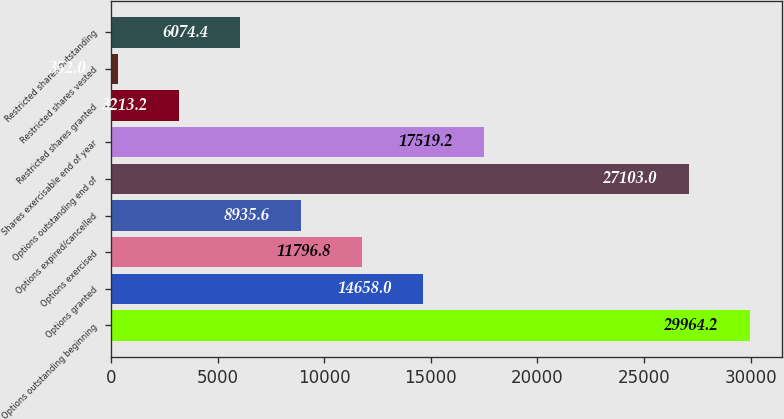Convert chart. <chart><loc_0><loc_0><loc_500><loc_500><bar_chart><fcel>Options outstanding beginning<fcel>Options granted<fcel>Options exercised<fcel>Options expired/cancelled<fcel>Options outstanding end of<fcel>Shares exercisable end of year<fcel>Restricted shares granted<fcel>Restricted shares vested<fcel>Restricted shares outstanding<nl><fcel>29964.2<fcel>14658<fcel>11796.8<fcel>8935.6<fcel>27103<fcel>17519.2<fcel>3213.2<fcel>352<fcel>6074.4<nl></chart> 